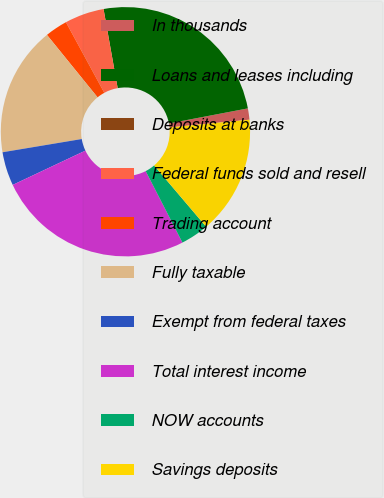Convert chart to OTSL. <chart><loc_0><loc_0><loc_500><loc_500><pie_chart><fcel>In thousands<fcel>Loans and leases including<fcel>Deposits at banks<fcel>Federal funds sold and resell<fcel>Trading account<fcel>Fully taxable<fcel>Exempt from federal taxes<fcel>Total interest income<fcel>NOW accounts<fcel>Savings deposits<nl><fcel>1.46%<fcel>24.81%<fcel>0.0%<fcel>5.11%<fcel>2.92%<fcel>16.79%<fcel>4.38%<fcel>25.54%<fcel>3.65%<fcel>15.33%<nl></chart> 